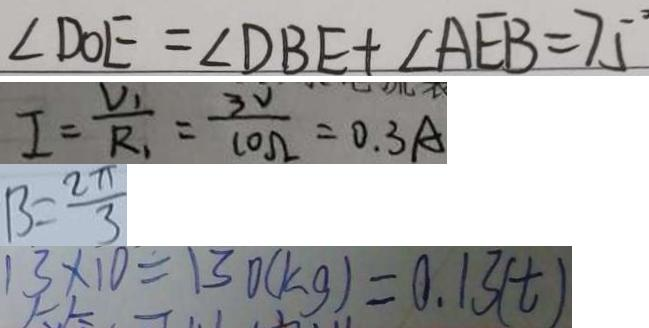<formula> <loc_0><loc_0><loc_500><loc_500>\angle D O E = \angle D B E + \angle A E B = 7 5 ^ { \circ } 
 I = \frac { V _ { 1 } } { R _ { 1 } } = \frac { 3 V } { 1 0 \Omega } = 0 . 3 A 
 B = \frac { 2 \pi } { 3 } 
 1 3 \times 1 0 = 1 3 0 ( k g ) = 0 . 1 3 ( t )</formula> 